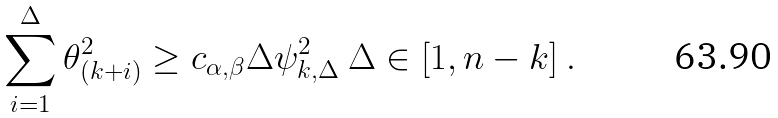Convert formula to latex. <formula><loc_0><loc_0><loc_500><loc_500>\sum _ { i = 1 } ^ { \Delta } \theta _ { ( k + i ) } ^ { 2 } \geq c _ { \alpha , \beta } \Delta \psi ^ { 2 } _ { k , \Delta } \ \Delta \in [ 1 , n - k ] \ .</formula> 